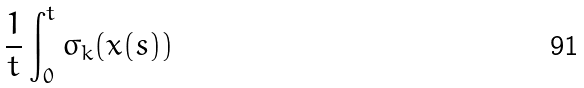Convert formula to latex. <formula><loc_0><loc_0><loc_500><loc_500>\frac { 1 } { t } \int _ { 0 } ^ { t } \sigma _ { k } ( x ( s ) )</formula> 